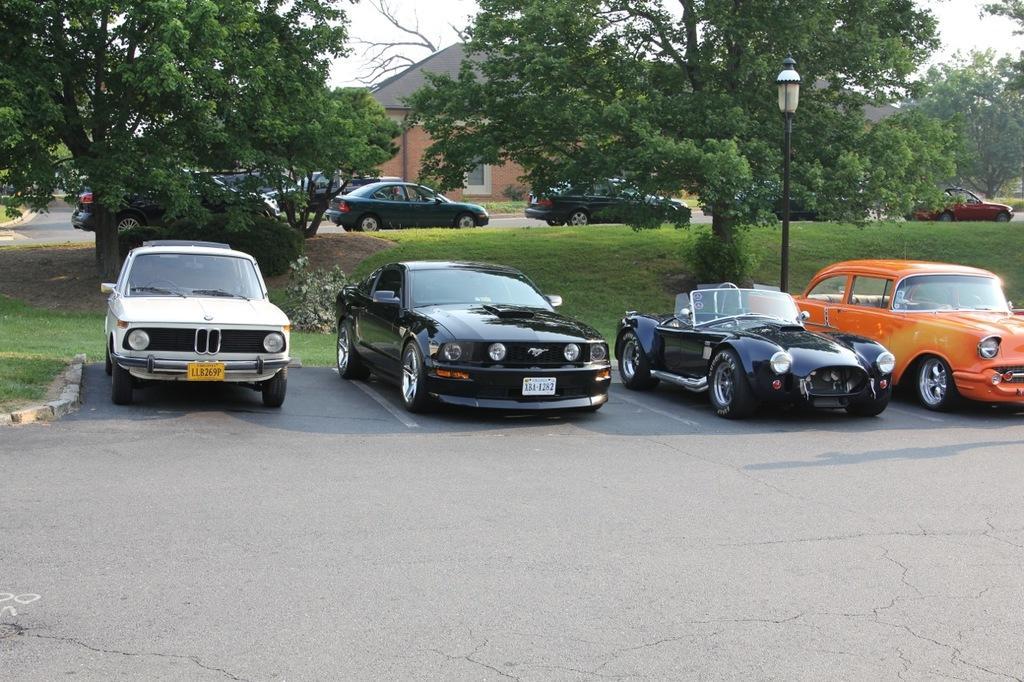Please provide a concise description of this image. In this picture we can see few cars on the road, beside to the cars we can find a light, metal rod and trees, in the background we can see a house. 